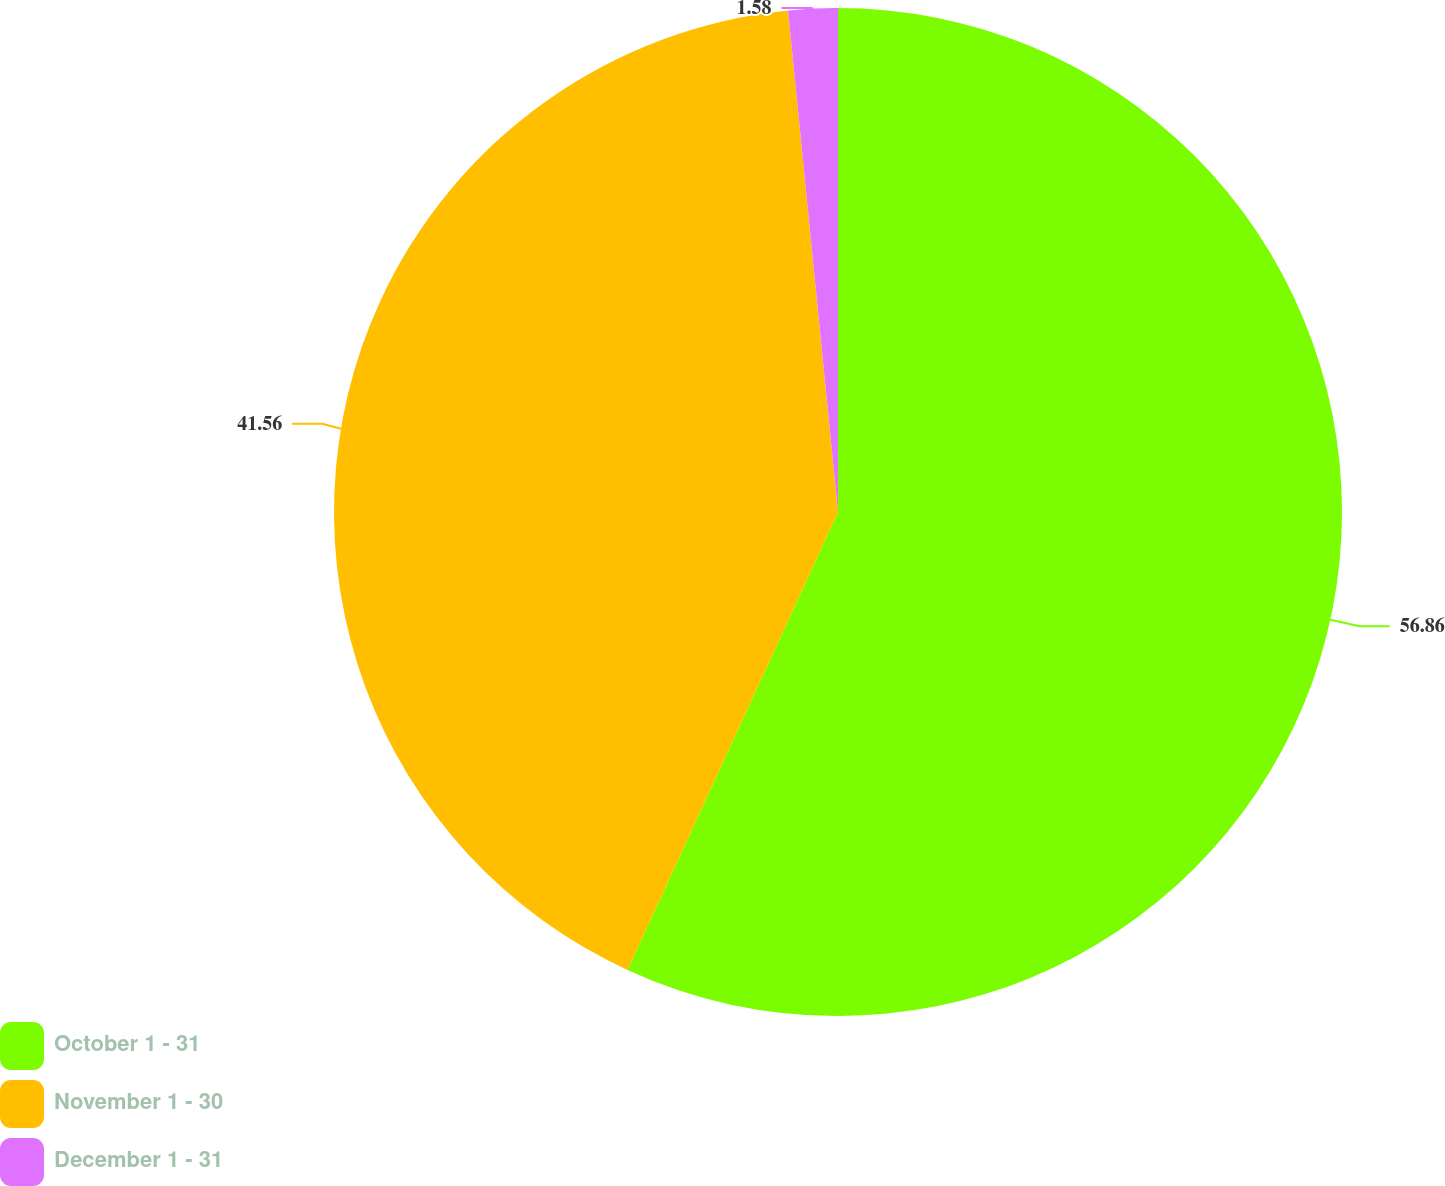Convert chart. <chart><loc_0><loc_0><loc_500><loc_500><pie_chart><fcel>October 1 - 31<fcel>November 1 - 30<fcel>December 1 - 31<nl><fcel>56.86%<fcel>41.56%<fcel>1.58%<nl></chart> 